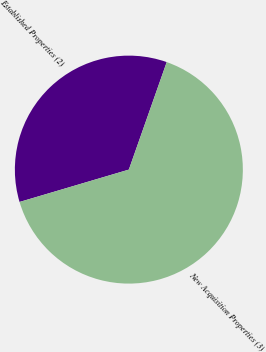Convert chart to OTSL. <chart><loc_0><loc_0><loc_500><loc_500><pie_chart><fcel>Established Properties (2)<fcel>New Acquisition Properties (3)<nl><fcel>34.97%<fcel>65.03%<nl></chart> 